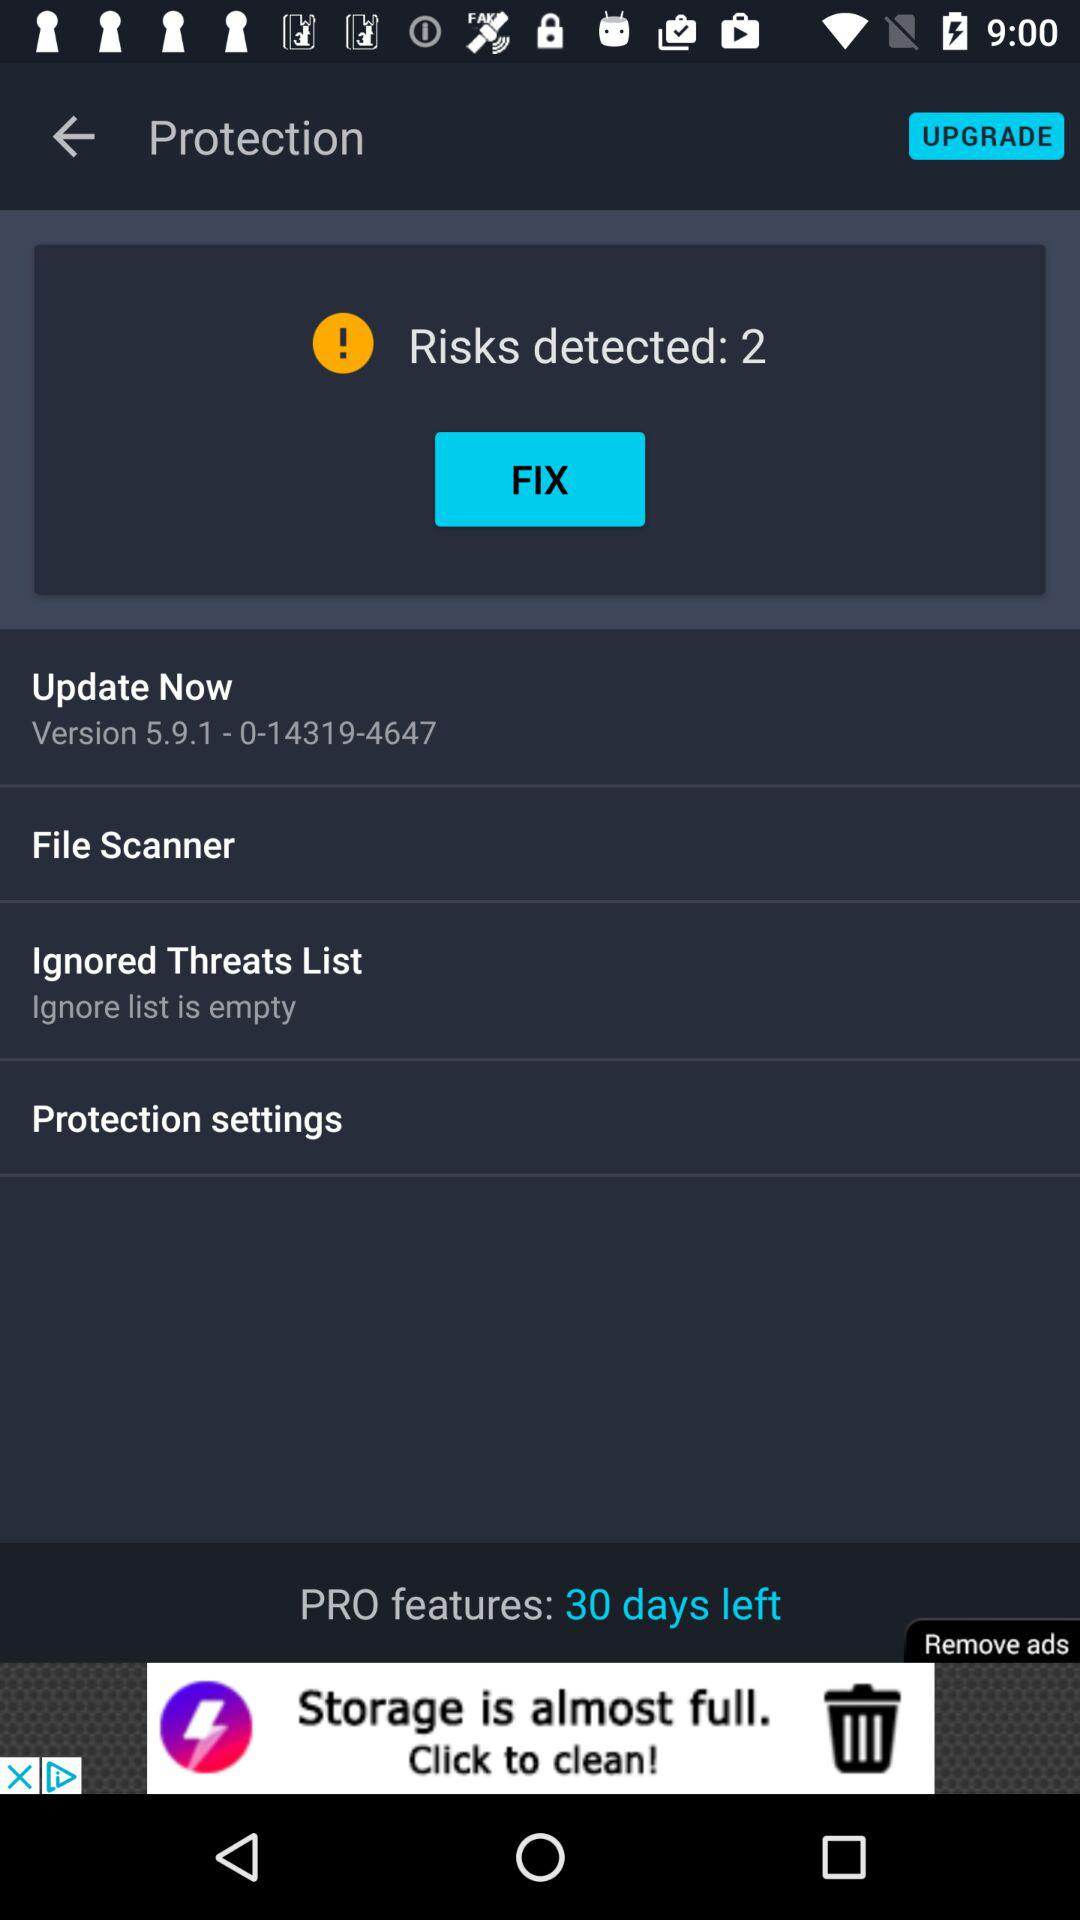How many risks are detected? There are 2 risks detected. 